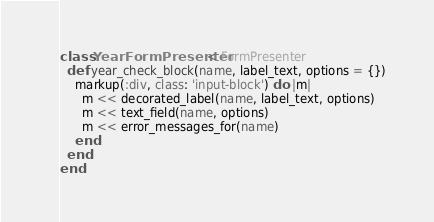<code> <loc_0><loc_0><loc_500><loc_500><_Ruby_>class YearFormPresenter < FormPresenter
  def year_check_block(name, label_text, options = {})
    markup(:div, class: 'input-block') do |m|
      m << decorated_label(name, label_text, options)
      m << text_field(name, options)
      m << error_messages_for(name)
    end
  end
end</code> 